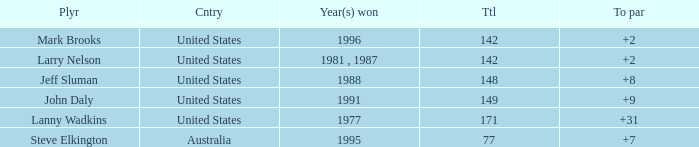Help me parse the entirety of this table. {'header': ['Plyr', 'Cntry', 'Year(s) won', 'Ttl', 'To par'], 'rows': [['Mark Brooks', 'United States', '1996', '142', '+2'], ['Larry Nelson', 'United States', '1981 , 1987', '142', '+2'], ['Jeff Sluman', 'United States', '1988', '148', '+8'], ['John Daly', 'United States', '1991', '149', '+9'], ['Lanny Wadkins', 'United States', '1977', '171', '+31'], ['Steve Elkington', 'Australia', '1995', '77', '+7']]} Name the Total of jeff sluman? 148.0. 